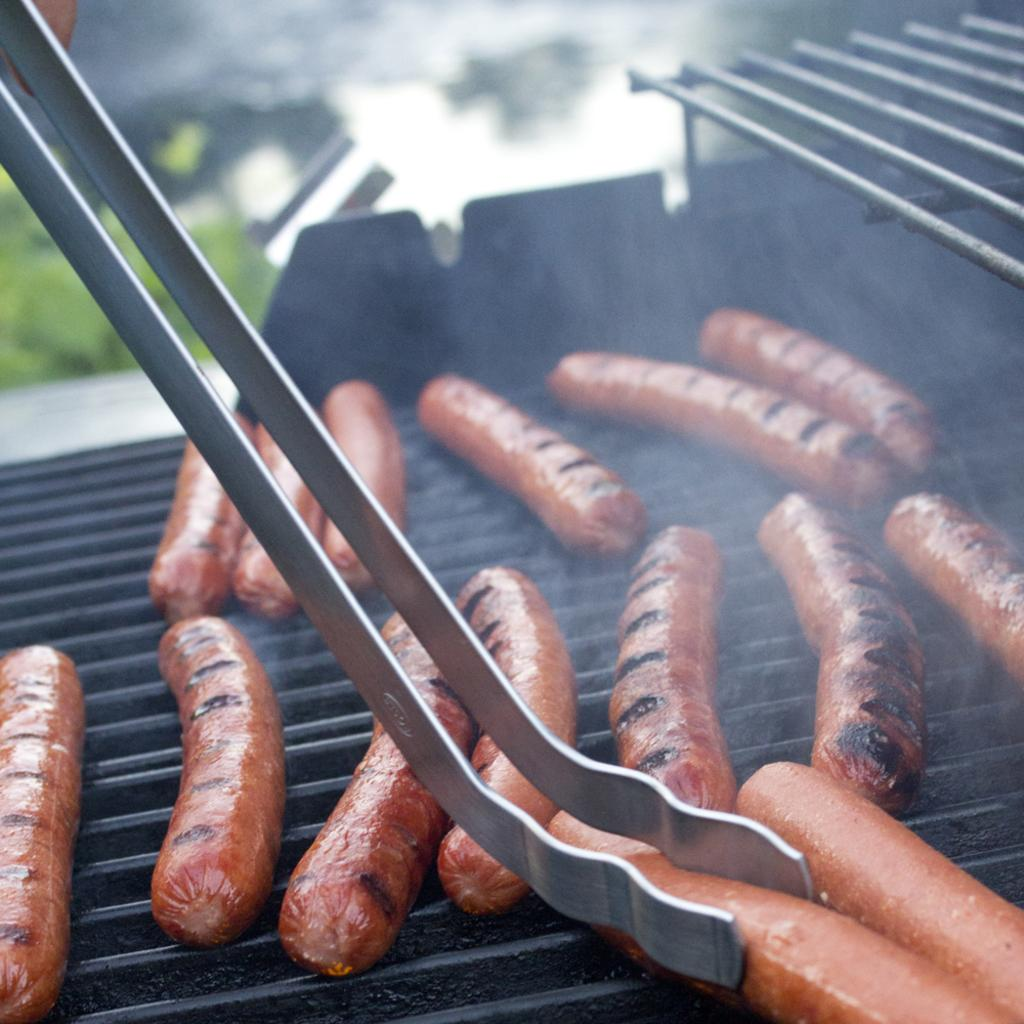What is being cooked on the grill in the image? There are sausages on a grill in the image. What tool is used to handle the sausages on the grill? Tongs are visible in the image. Can you describe the background of the image? There is a person's hand and plants present in the background of the image. What time of day is the image likely taken? The image is likely taken during the day, as there is sufficient light to see the sausages on the grill. What type of soap is being used to clean the fish in the image? There is no soap or fish present in the image; it features sausages on a grill and other related items. 